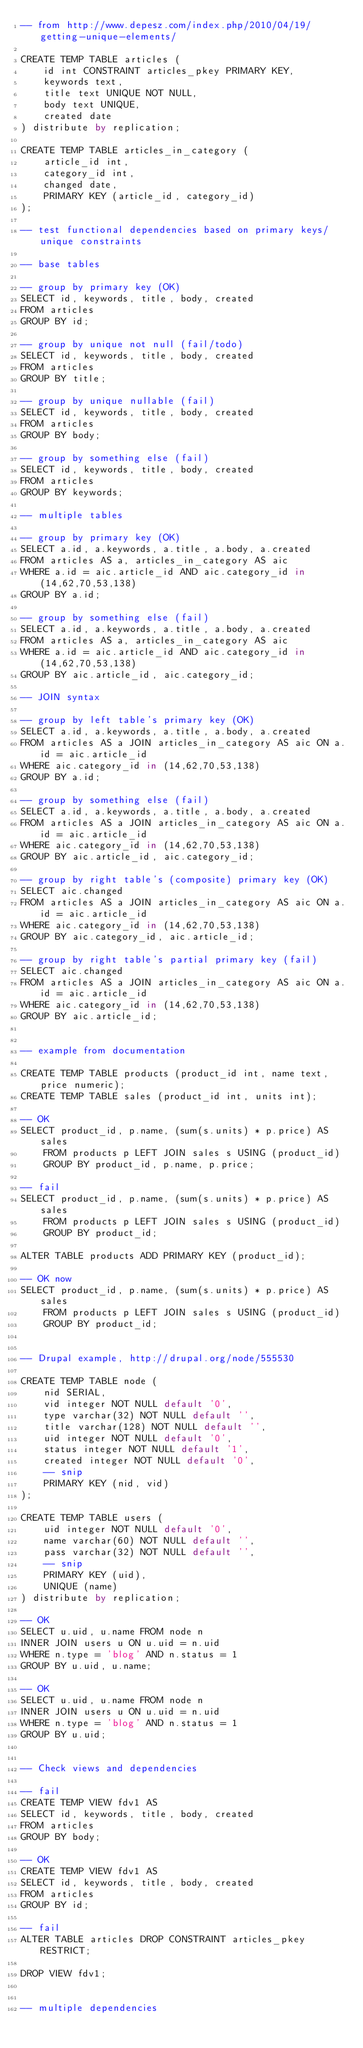Convert code to text. <code><loc_0><loc_0><loc_500><loc_500><_SQL_>-- from http://www.depesz.com/index.php/2010/04/19/getting-unique-elements/

CREATE TEMP TABLE articles (
    id int CONSTRAINT articles_pkey PRIMARY KEY,
    keywords text,
    title text UNIQUE NOT NULL,
    body text UNIQUE,
    created date
) distribute by replication;

CREATE TEMP TABLE articles_in_category (
    article_id int,
    category_id int,
    changed date,
    PRIMARY KEY (article_id, category_id)
);

-- test functional dependencies based on primary keys/unique constraints

-- base tables

-- group by primary key (OK)
SELECT id, keywords, title, body, created
FROM articles
GROUP BY id;

-- group by unique not null (fail/todo)
SELECT id, keywords, title, body, created
FROM articles
GROUP BY title;

-- group by unique nullable (fail)
SELECT id, keywords, title, body, created
FROM articles
GROUP BY body;

-- group by something else (fail)
SELECT id, keywords, title, body, created
FROM articles
GROUP BY keywords;

-- multiple tables

-- group by primary key (OK)
SELECT a.id, a.keywords, a.title, a.body, a.created
FROM articles AS a, articles_in_category AS aic
WHERE a.id = aic.article_id AND aic.category_id in (14,62,70,53,138)
GROUP BY a.id;

-- group by something else (fail)
SELECT a.id, a.keywords, a.title, a.body, a.created
FROM articles AS a, articles_in_category AS aic
WHERE a.id = aic.article_id AND aic.category_id in (14,62,70,53,138)
GROUP BY aic.article_id, aic.category_id;

-- JOIN syntax

-- group by left table's primary key (OK)
SELECT a.id, a.keywords, a.title, a.body, a.created
FROM articles AS a JOIN articles_in_category AS aic ON a.id = aic.article_id
WHERE aic.category_id in (14,62,70,53,138)
GROUP BY a.id;

-- group by something else (fail)
SELECT a.id, a.keywords, a.title, a.body, a.created
FROM articles AS a JOIN articles_in_category AS aic ON a.id = aic.article_id
WHERE aic.category_id in (14,62,70,53,138)
GROUP BY aic.article_id, aic.category_id;

-- group by right table's (composite) primary key (OK)
SELECT aic.changed
FROM articles AS a JOIN articles_in_category AS aic ON a.id = aic.article_id
WHERE aic.category_id in (14,62,70,53,138)
GROUP BY aic.category_id, aic.article_id;

-- group by right table's partial primary key (fail)
SELECT aic.changed
FROM articles AS a JOIN articles_in_category AS aic ON a.id = aic.article_id
WHERE aic.category_id in (14,62,70,53,138)
GROUP BY aic.article_id;


-- example from documentation

CREATE TEMP TABLE products (product_id int, name text, price numeric);
CREATE TEMP TABLE sales (product_id int, units int);

-- OK
SELECT product_id, p.name, (sum(s.units) * p.price) AS sales
    FROM products p LEFT JOIN sales s USING (product_id)
    GROUP BY product_id, p.name, p.price;

-- fail
SELECT product_id, p.name, (sum(s.units) * p.price) AS sales
    FROM products p LEFT JOIN sales s USING (product_id)
    GROUP BY product_id;

ALTER TABLE products ADD PRIMARY KEY (product_id);

-- OK now
SELECT product_id, p.name, (sum(s.units) * p.price) AS sales
    FROM products p LEFT JOIN sales s USING (product_id)
    GROUP BY product_id;


-- Drupal example, http://drupal.org/node/555530

CREATE TEMP TABLE node (
    nid SERIAL,
    vid integer NOT NULL default '0',
    type varchar(32) NOT NULL default '',
    title varchar(128) NOT NULL default '',
    uid integer NOT NULL default '0',
    status integer NOT NULL default '1',
    created integer NOT NULL default '0',
    -- snip
    PRIMARY KEY (nid, vid)
);

CREATE TEMP TABLE users (
    uid integer NOT NULL default '0',
    name varchar(60) NOT NULL default '',
    pass varchar(32) NOT NULL default '',
    -- snip
    PRIMARY KEY (uid),
    UNIQUE (name)
) distribute by replication;

-- OK
SELECT u.uid, u.name FROM node n
INNER JOIN users u ON u.uid = n.uid
WHERE n.type = 'blog' AND n.status = 1
GROUP BY u.uid, u.name;

-- OK
SELECT u.uid, u.name FROM node n
INNER JOIN users u ON u.uid = n.uid
WHERE n.type = 'blog' AND n.status = 1
GROUP BY u.uid;


-- Check views and dependencies

-- fail
CREATE TEMP VIEW fdv1 AS
SELECT id, keywords, title, body, created
FROM articles
GROUP BY body;

-- OK
CREATE TEMP VIEW fdv1 AS
SELECT id, keywords, title, body, created
FROM articles
GROUP BY id;

-- fail
ALTER TABLE articles DROP CONSTRAINT articles_pkey RESTRICT;

DROP VIEW fdv1;


-- multiple dependencies</code> 